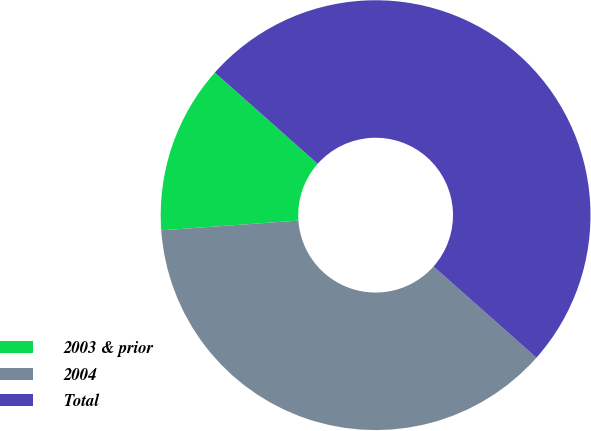Convert chart to OTSL. <chart><loc_0><loc_0><loc_500><loc_500><pie_chart><fcel>2003 & prior<fcel>2004<fcel>Total<nl><fcel>12.67%<fcel>37.33%<fcel>50.0%<nl></chart> 